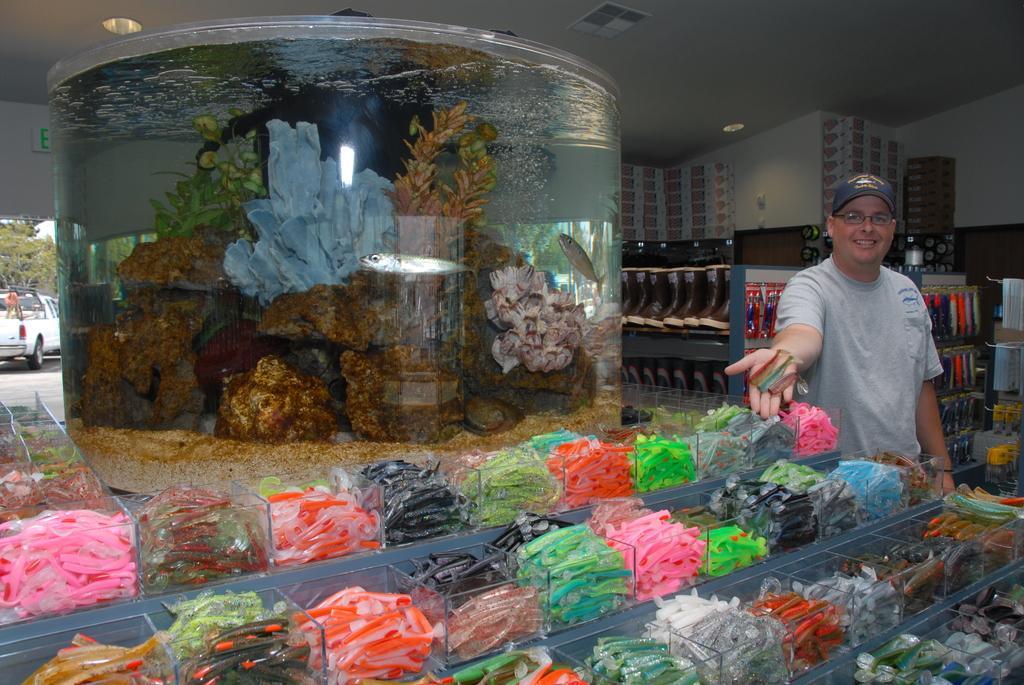Describe this image in one or two sentences. In this image in front there are candies in the jars. In the center of the image there is an aquarium. On the right side of the image there is a person holding the candies. Behind him there are shoes in the rack and there are few other objects. On top of the image there are lights. There is a wall. In the background of the image there are cars on the road and there are trees. 